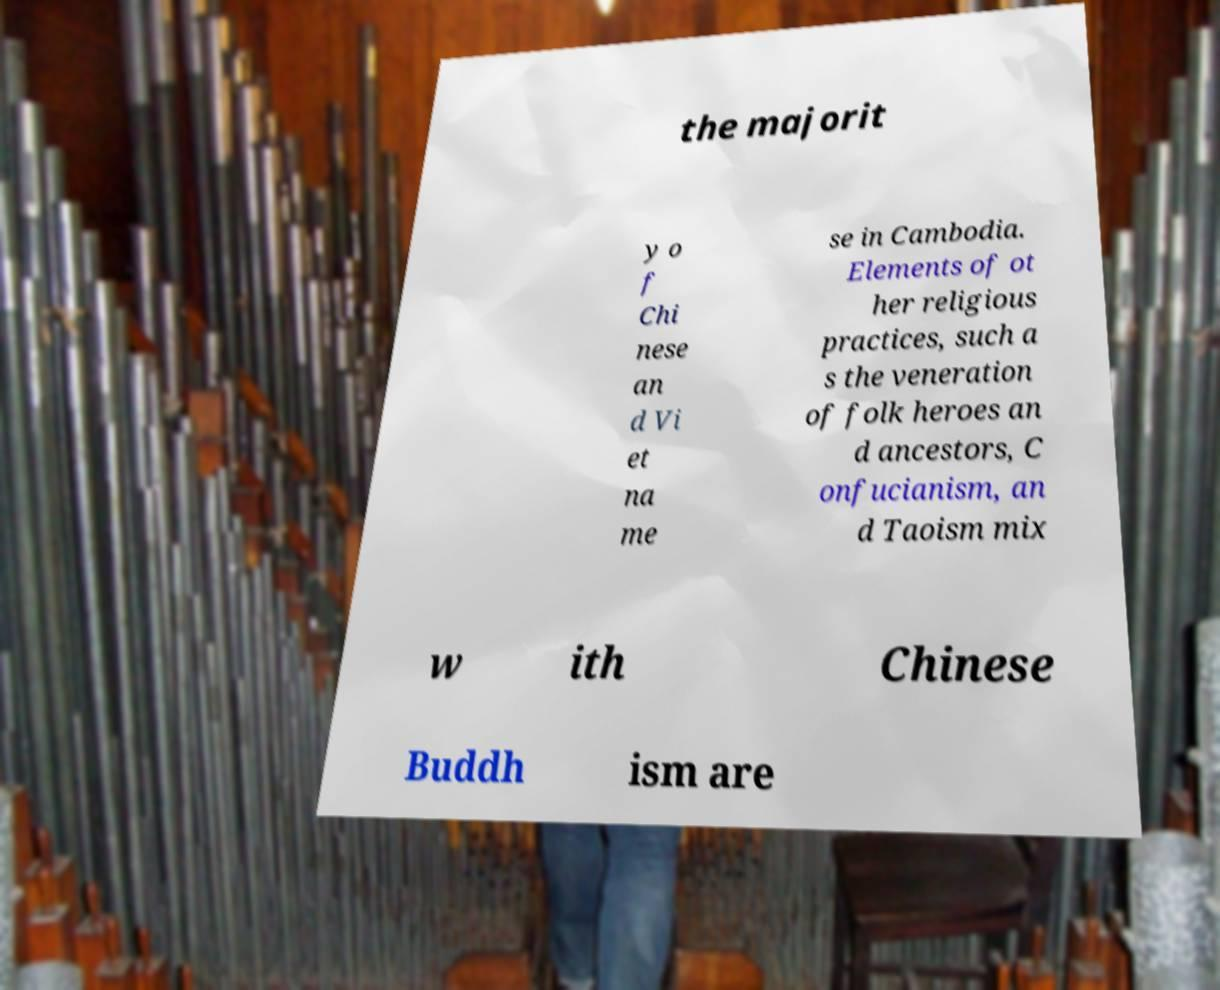I need the written content from this picture converted into text. Can you do that? the majorit y o f Chi nese an d Vi et na me se in Cambodia. Elements of ot her religious practices, such a s the veneration of folk heroes an d ancestors, C onfucianism, an d Taoism mix w ith Chinese Buddh ism are 